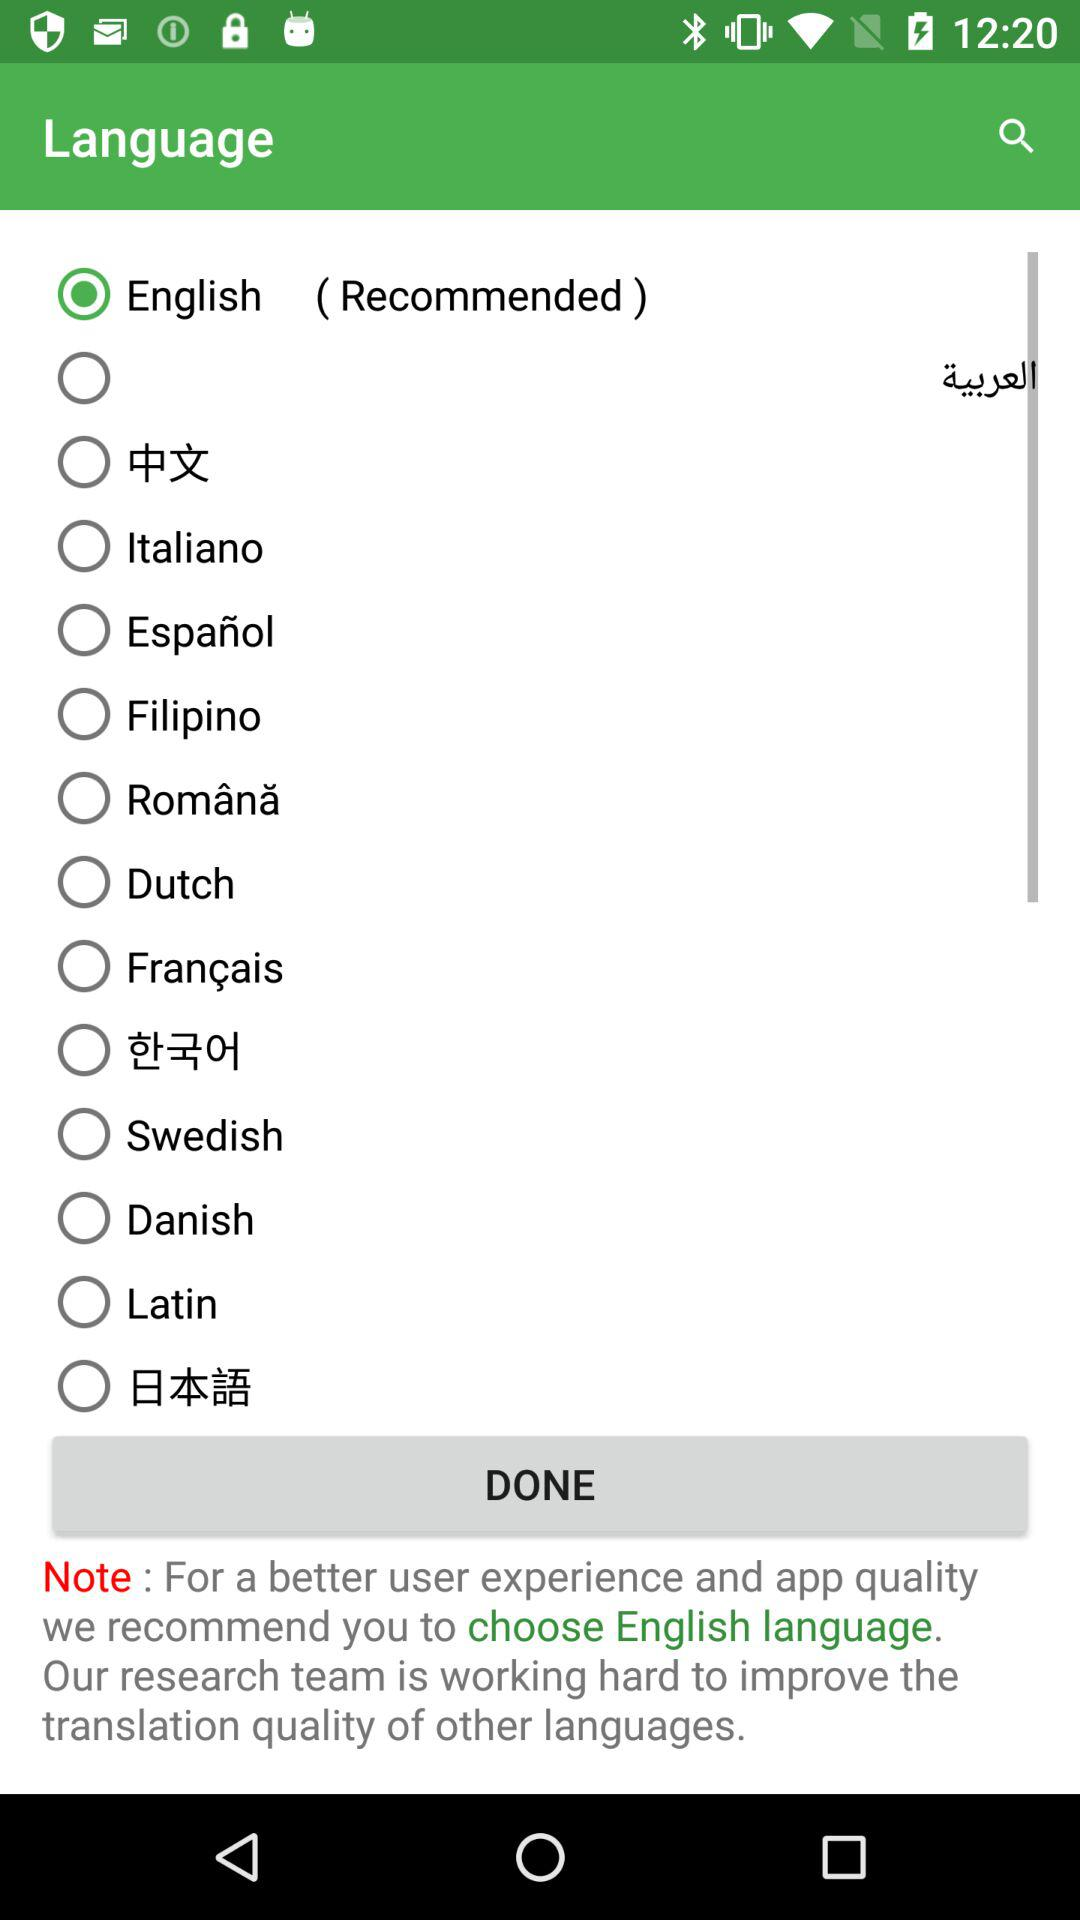What's the selected language? The selected language is English. 